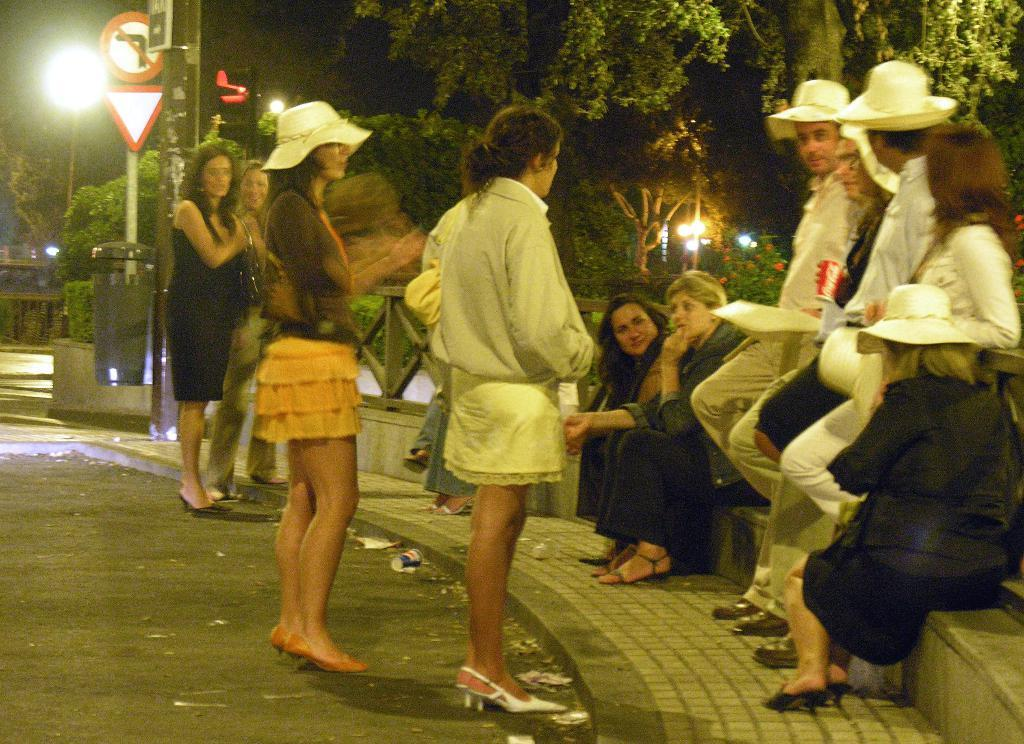How many people are in the image? There is a group of people in the image, but the exact number is not specified. What are the people in the image doing? Some people are sitting, while others are standing. What can be seen in the background of the image? There are trees visible in the background of the image. What is the color of the trees in the image? The trees are green in color. What other objects can be seen in the image? There is a sign board and a light pole in the image. Can you see any planes or trains in the image? No, there are no planes or trains visible in the image. Are there any cattle present in the image? No, there are no cattle present in the image. 